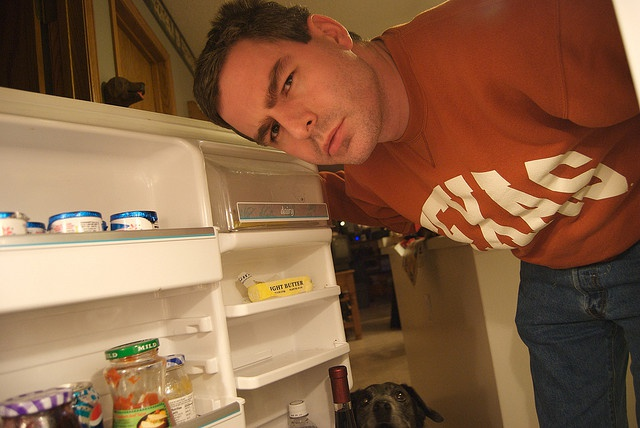Describe the objects in this image and their specific colors. I can see people in black, maroon, and brown tones, refrigerator in black, tan, gray, and beige tones, dog in black, maroon, and olive tones, and bottle in black, maroon, and gray tones in this image. 